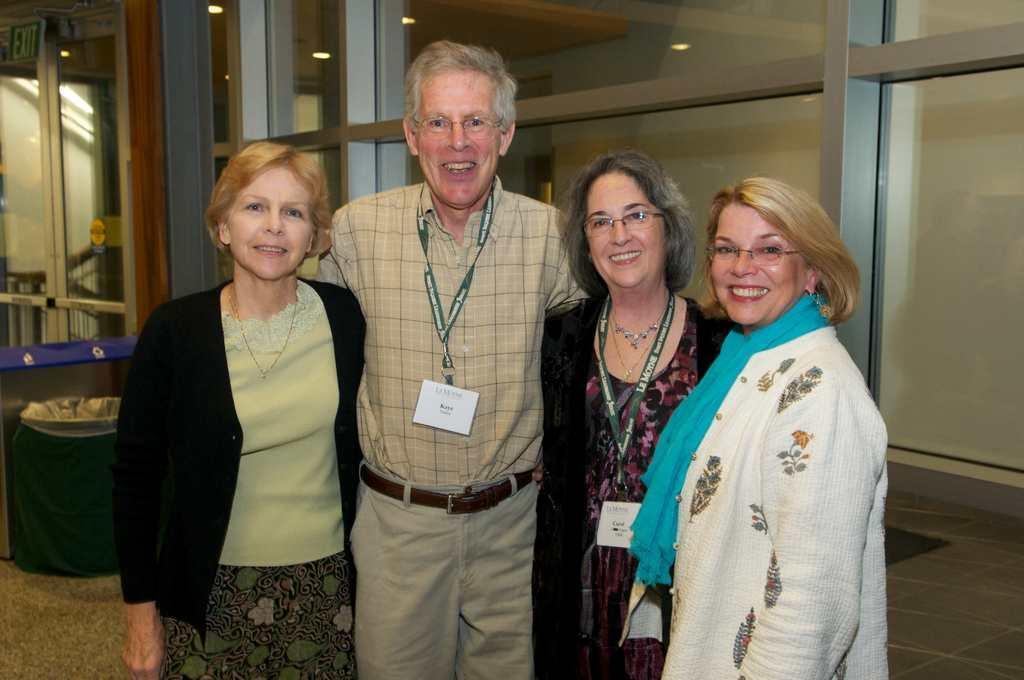Please provide a concise description of this image. In this picture I can see 3 women and a man who are standing in front and I see that they are smiling. In the background I can see the glasses and on the top of this picture I can see the lights. 